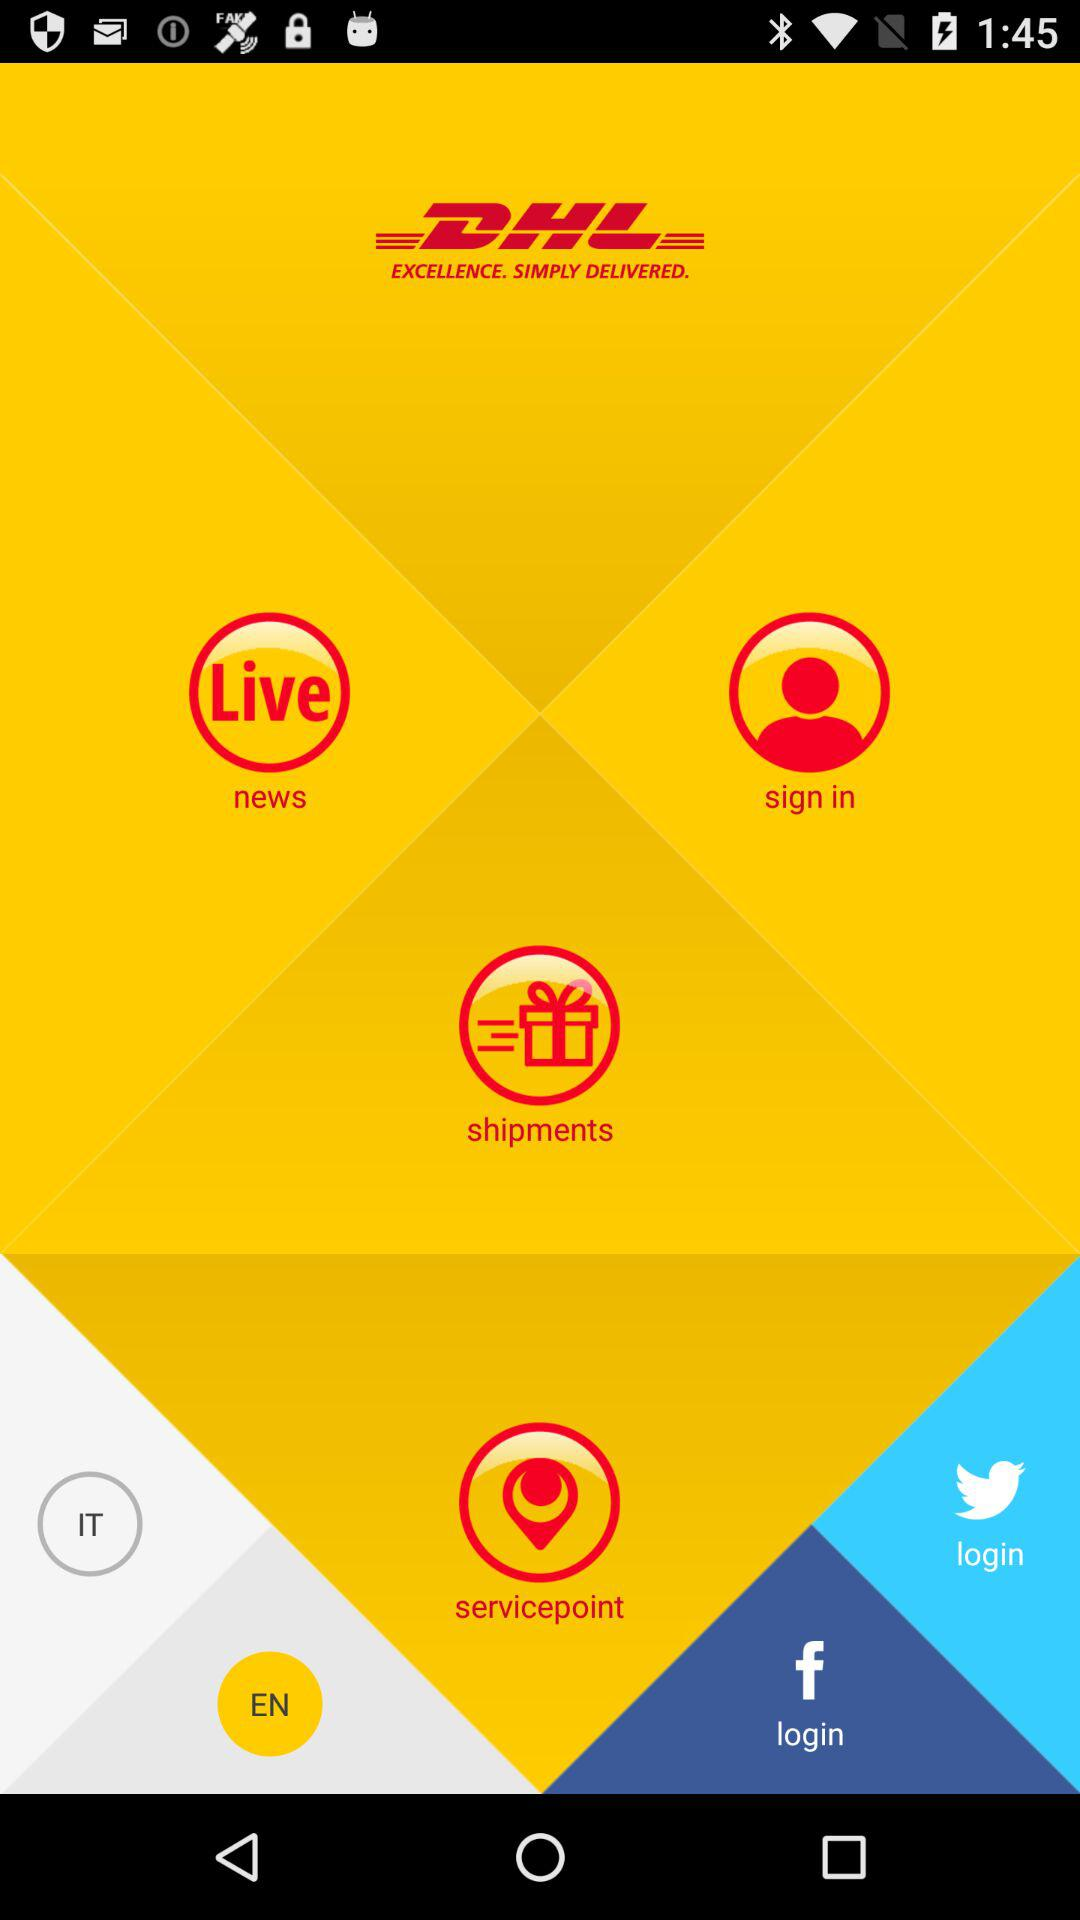What are the login options? The login options are "Facebook" and "Twitter". 